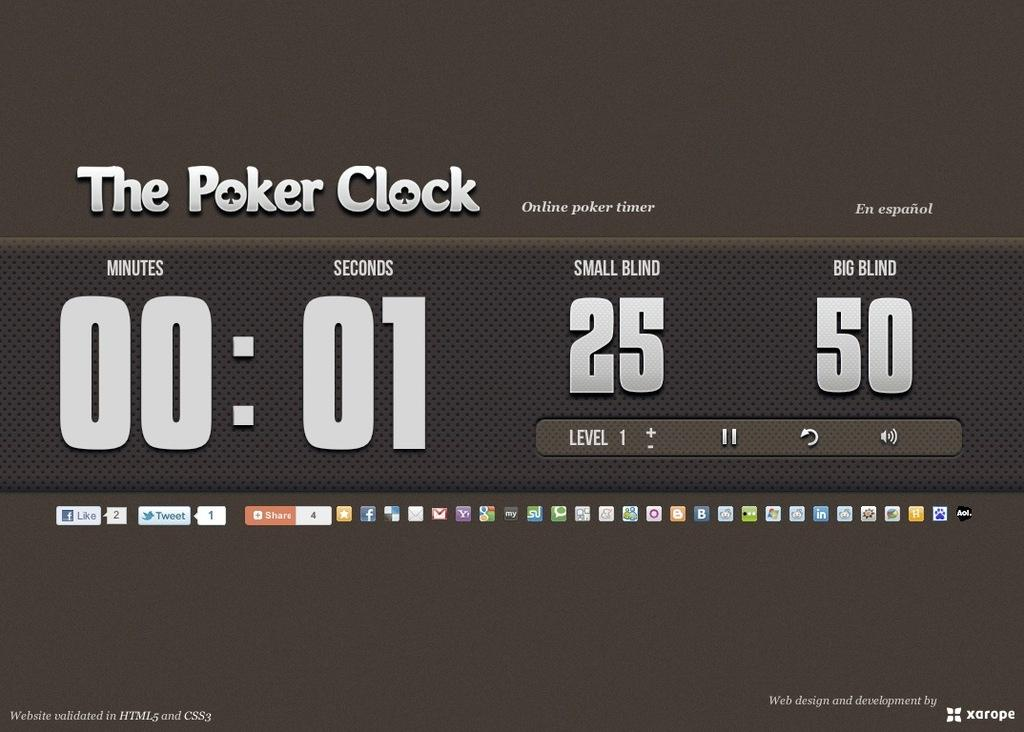What is the main object in the center of the image? There is a board in the center of the image. What can be seen on the board? There is text written on the board. How many family members are holding celery in the image? There is no family or celery present in the image; it only features a board with text. 